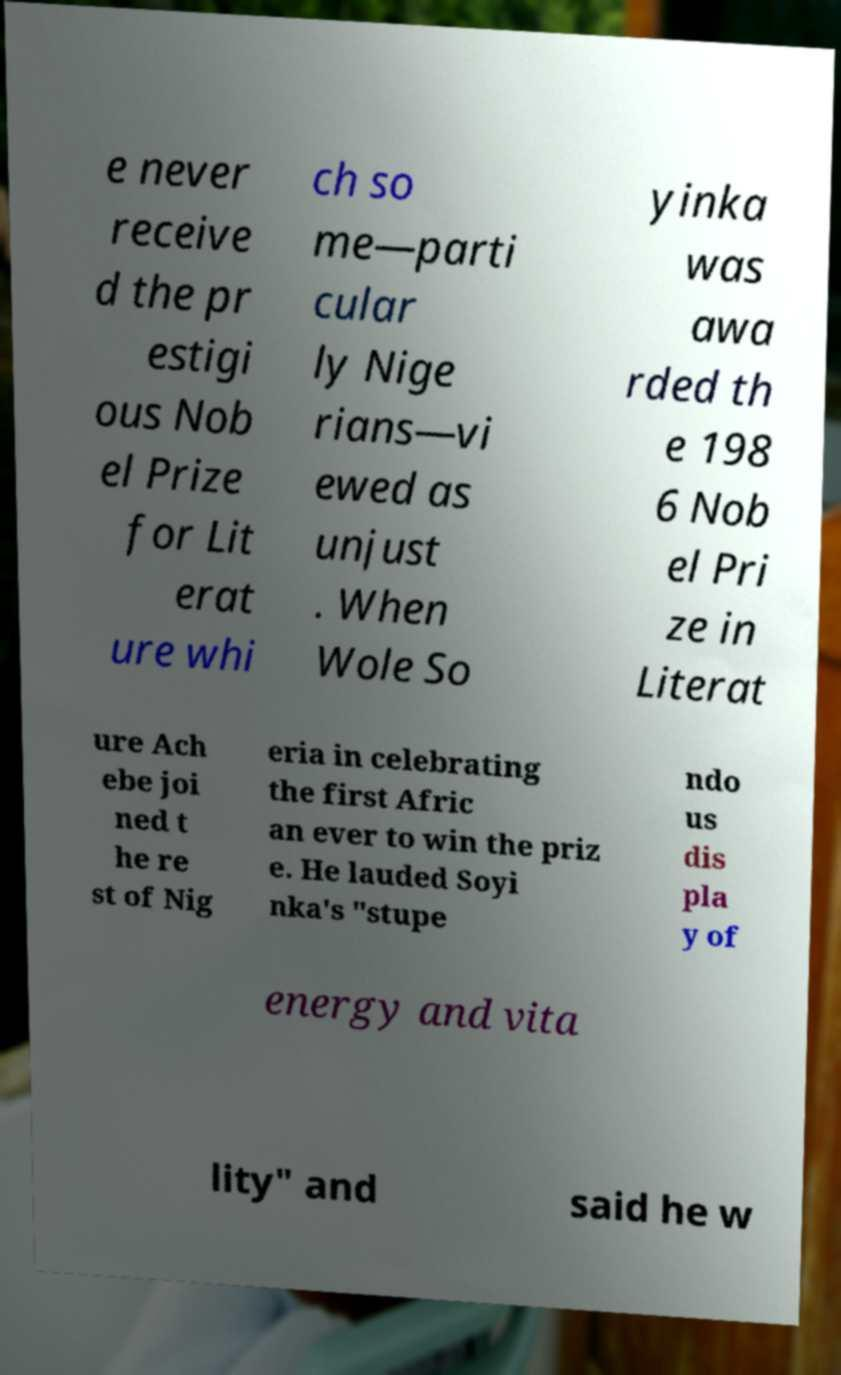Please identify and transcribe the text found in this image. e never receive d the pr estigi ous Nob el Prize for Lit erat ure whi ch so me—parti cular ly Nige rians—vi ewed as unjust . When Wole So yinka was awa rded th e 198 6 Nob el Pri ze in Literat ure Ach ebe joi ned t he re st of Nig eria in celebrating the first Afric an ever to win the priz e. He lauded Soyi nka's "stupe ndo us dis pla y of energy and vita lity" and said he w 